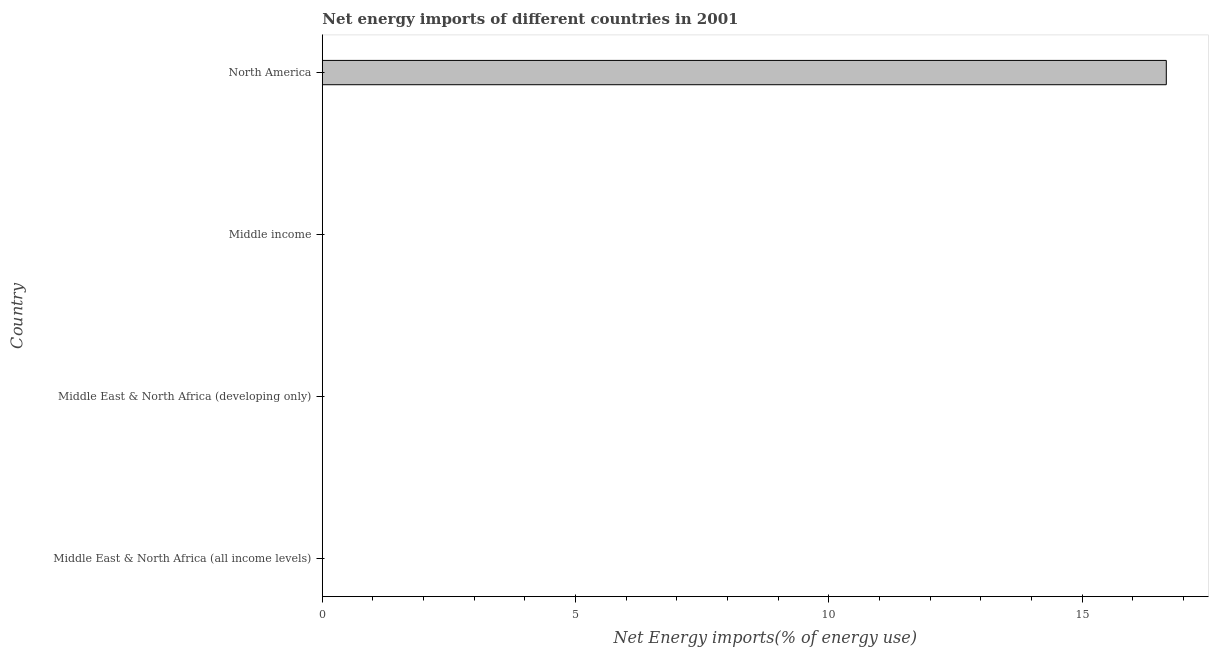Does the graph contain any zero values?
Your answer should be compact. Yes. What is the title of the graph?
Your answer should be compact. Net energy imports of different countries in 2001. What is the label or title of the X-axis?
Your answer should be very brief. Net Energy imports(% of energy use). What is the label or title of the Y-axis?
Give a very brief answer. Country. Across all countries, what is the maximum energy imports?
Your response must be concise. 16.66. Across all countries, what is the minimum energy imports?
Your response must be concise. 0. What is the sum of the energy imports?
Keep it short and to the point. 16.66. What is the average energy imports per country?
Your response must be concise. 4.17. In how many countries, is the energy imports greater than 10 %?
Offer a terse response. 1. What is the difference between the highest and the lowest energy imports?
Keep it short and to the point. 16.66. In how many countries, is the energy imports greater than the average energy imports taken over all countries?
Offer a terse response. 1. Are all the bars in the graph horizontal?
Provide a succinct answer. Yes. How many countries are there in the graph?
Give a very brief answer. 4. What is the difference between two consecutive major ticks on the X-axis?
Ensure brevity in your answer.  5. Are the values on the major ticks of X-axis written in scientific E-notation?
Make the answer very short. No. What is the Net Energy imports(% of energy use) in Middle East & North Africa (developing only)?
Provide a succinct answer. 0. What is the Net Energy imports(% of energy use) of Middle income?
Provide a short and direct response. 0. What is the Net Energy imports(% of energy use) in North America?
Your answer should be compact. 16.66. 